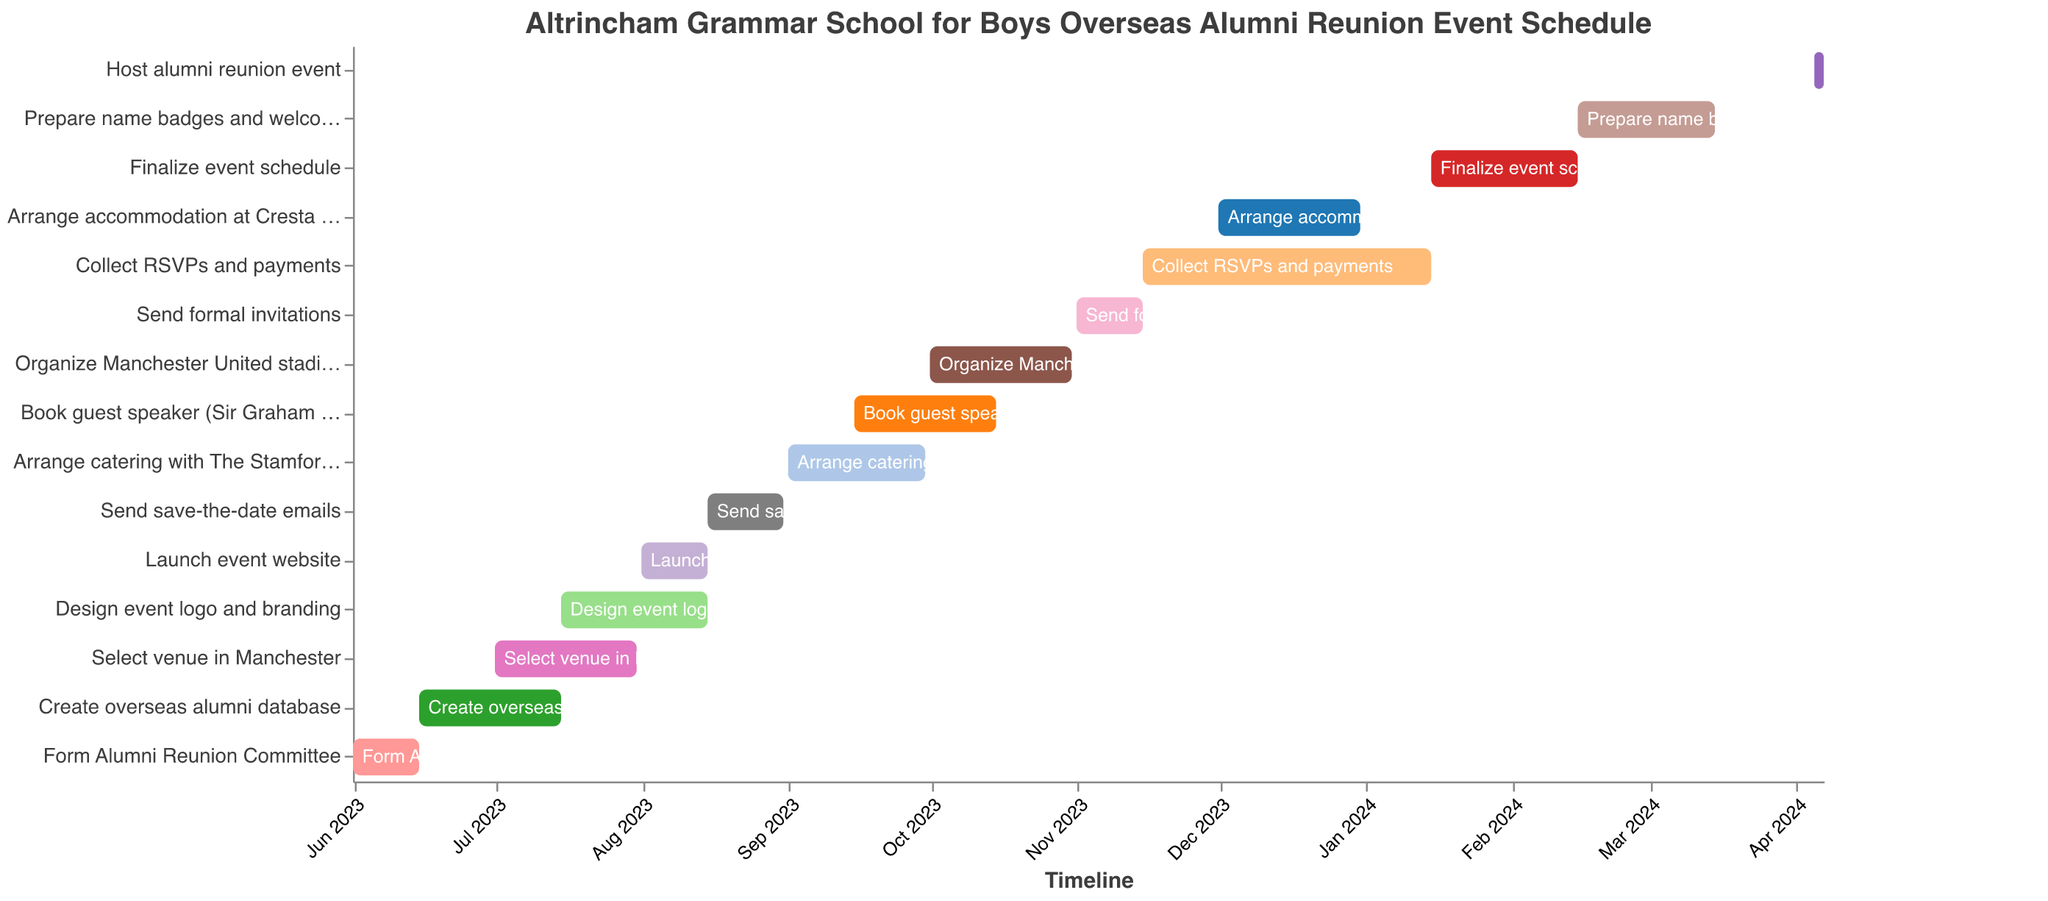What is the title of the chart? The title of the chart is displayed at the top and it reads "Altrincham Grammar School for Boys Overseas Alumni Reunion Event Schedule."
Answer: Altrincham Grammar School for Boys Overseas Alumni Reunion Event Schedule What is the duration of the task "Form Alumni Reunion Committee"? This task starts on 2023-06-01 and ends on 2023-06-15. The duration can be calculated by counting the days between the start and end date. Therefore, it lasts 15 days.
Answer: 15 days Which task has the longest duration? By examining the start and end dates of each task, the task "Collect RSVPs and payments" has the longest duration, starting on 2023-11-15 and ending on 2024-01-15, lasting 62 days.
Answer: Collect RSVPs and payments How many tasks are scheduled to start in July 2023? By examining the start dates in the dataset, the tasks "Select venue in Manchester" and "Design event logo and branding" both start in July 2023. That totals to two tasks.
Answer: 2 tasks Which tasks are scheduled to be completed by the end of August 2023? Inspecting the end dates in the dataset, the tasks "Form Alumni Reunion Committee", "Create overseas alumni database", "Select venue in Manchester", "Design event logo and branding", and "Launch event website" are all completed by 2023-08-31.
Answer: 5 tasks During which months does the task "Arrange catering with The Stamford Arms" occur? This task starts on 2023-09-01 and ends on 2023-09-30. Therefore, it occurs in September 2023.
Answer: September 2023 Which task overlaps with the "Book guest speaker (Sir Graham Brady MP)"? Checking the dates, the task "Arrange catering with The Stamford Arms" overlaps with "Book guest speaker" as it starts on 2023-09-01 and ends on 2023-09-30, while "Book guest speaker" starts on 2023-09-15.
Answer: Arrange catering with The Stamford Arms What is the duration of the final event preparation task before the reunion event? The final event preparation task before the actual reunion event is "Prepare name badges and welcome packs," which starts on 2024-02-15 and ends on 2024-03-15, lasting 29 days.
Answer: 29 days On what date should the event's final schedule be ready? According to the dataset, the "Finalize event schedule" task ends on 2024-02-15, so the final schedule should be ready by that date.
Answer: 2024-02-15 